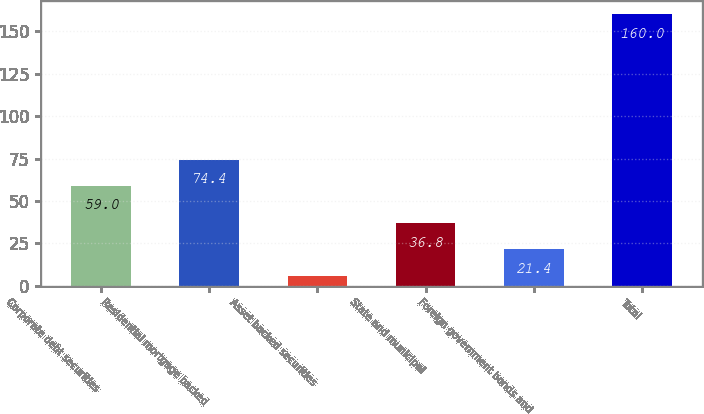<chart> <loc_0><loc_0><loc_500><loc_500><bar_chart><fcel>Corporate debt securities<fcel>Residential mortgage backed<fcel>Asset backed securities<fcel>State and municipal<fcel>Foreign government bonds and<fcel>Total<nl><fcel>59<fcel>74.4<fcel>6<fcel>36.8<fcel>21.4<fcel>160<nl></chart> 